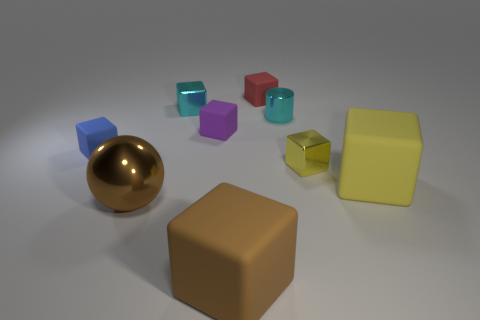Subtract all cyan cylinders. How many yellow blocks are left? 2 Subtract all purple cubes. How many cubes are left? 6 Subtract all tiny red cubes. How many cubes are left? 6 Add 1 brown matte cylinders. How many objects exist? 10 Subtract all blue cubes. Subtract all blue spheres. How many cubes are left? 6 Subtract all balls. How many objects are left? 8 Subtract 0 red spheres. How many objects are left? 9 Subtract all large spheres. Subtract all red matte cubes. How many objects are left? 7 Add 8 small cyan objects. How many small cyan objects are left? 10 Add 6 metallic balls. How many metallic balls exist? 7 